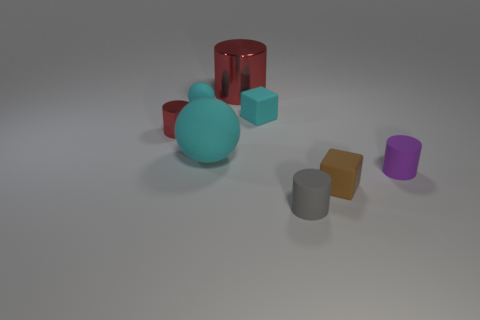Subtract 2 cylinders. How many cylinders are left? 2 Add 1 red cylinders. How many objects exist? 9 Subtract all green cylinders. Subtract all purple blocks. How many cylinders are left? 4 Subtract all balls. How many objects are left? 6 Subtract all purple cylinders. Subtract all red cylinders. How many objects are left? 5 Add 1 gray cylinders. How many gray cylinders are left? 2 Add 5 tiny purple cylinders. How many tiny purple cylinders exist? 6 Subtract 0 green spheres. How many objects are left? 8 